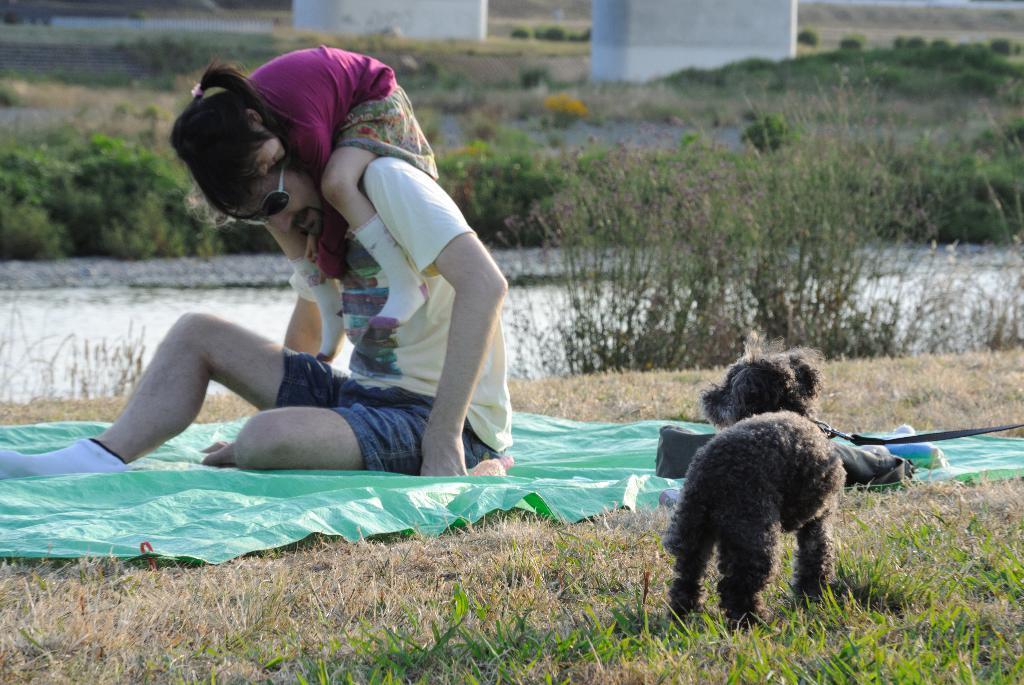In one or two sentences, can you explain what this image depicts? Here we can see a man sitting on a cover. On his shoulders we can see a kid. This is grass and there is a kid. In the background we can see plants and there is a wall. 